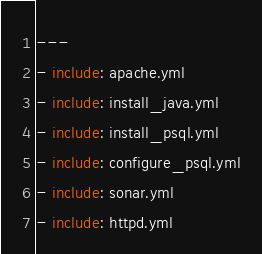Convert code to text. <code><loc_0><loc_0><loc_500><loc_500><_YAML_>---
- include: apache.yml
- include: install_java.yml
- include: install_psql.yml
- include: configure_psql.yml
- include: sonar.yml
- include: httpd.yml</code> 